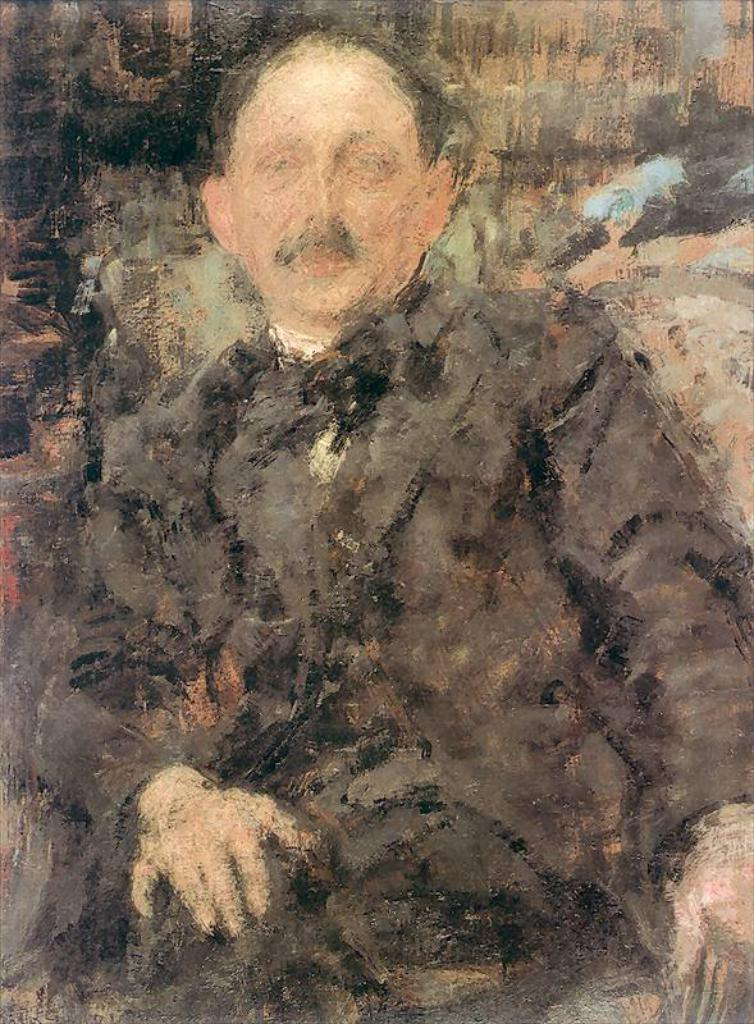What is the main subject of the painting in the image? There is a painting of a person in the image. What type of drug is the person holding in the painting? There is no drug present in the painting; it features a person. What kind of animal can be seen interacting with the person in the painting? There is no animal present in the painting; it features a person. 